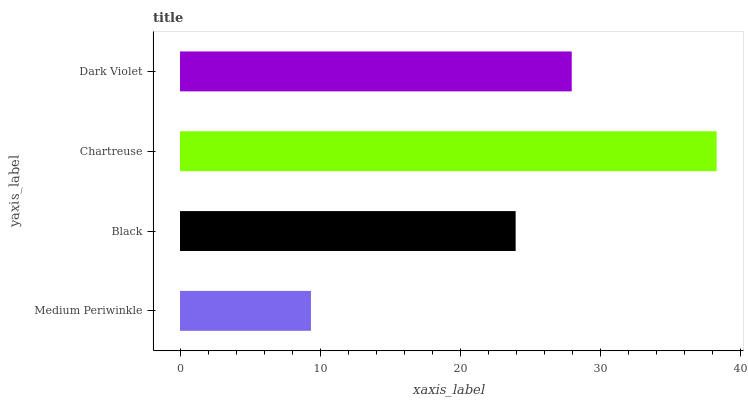Is Medium Periwinkle the minimum?
Answer yes or no. Yes. Is Chartreuse the maximum?
Answer yes or no. Yes. Is Black the minimum?
Answer yes or no. No. Is Black the maximum?
Answer yes or no. No. Is Black greater than Medium Periwinkle?
Answer yes or no. Yes. Is Medium Periwinkle less than Black?
Answer yes or no. Yes. Is Medium Periwinkle greater than Black?
Answer yes or no. No. Is Black less than Medium Periwinkle?
Answer yes or no. No. Is Dark Violet the high median?
Answer yes or no. Yes. Is Black the low median?
Answer yes or no. Yes. Is Chartreuse the high median?
Answer yes or no. No. Is Medium Periwinkle the low median?
Answer yes or no. No. 